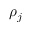Convert formula to latex. <formula><loc_0><loc_0><loc_500><loc_500>\rho _ { j }</formula> 